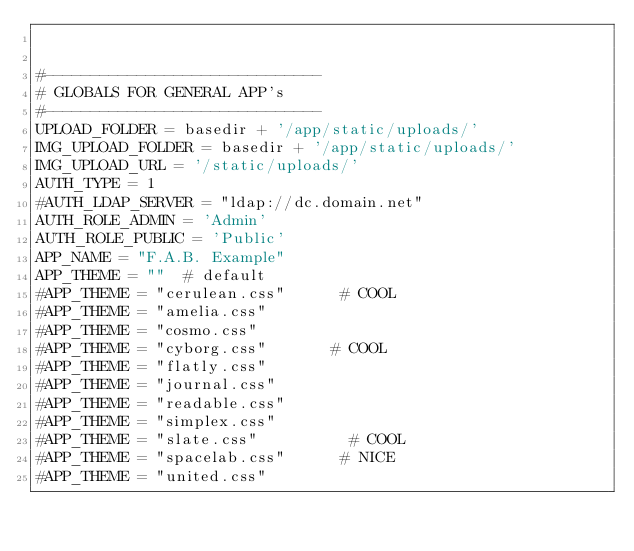<code> <loc_0><loc_0><loc_500><loc_500><_Python_>

#------------------------------
# GLOBALS FOR GENERAL APP's
#------------------------------
UPLOAD_FOLDER = basedir + '/app/static/uploads/'
IMG_UPLOAD_FOLDER = basedir + '/app/static/uploads/'
IMG_UPLOAD_URL = '/static/uploads/'
AUTH_TYPE = 1
#AUTH_LDAP_SERVER = "ldap://dc.domain.net"
AUTH_ROLE_ADMIN = 'Admin'
AUTH_ROLE_PUBLIC = 'Public'
APP_NAME = "F.A.B. Example"
APP_THEME = ""  # default
#APP_THEME = "cerulean.css"      # COOL
#APP_THEME = "amelia.css"
#APP_THEME = "cosmo.css"
#APP_THEME = "cyborg.css"       # COOL
#APP_THEME = "flatly.css"
#APP_THEME = "journal.css"
#APP_THEME = "readable.css"
#APP_THEME = "simplex.css"
#APP_THEME = "slate.css"          # COOL
#APP_THEME = "spacelab.css"      # NICE
#APP_THEME = "united.css"
</code> 